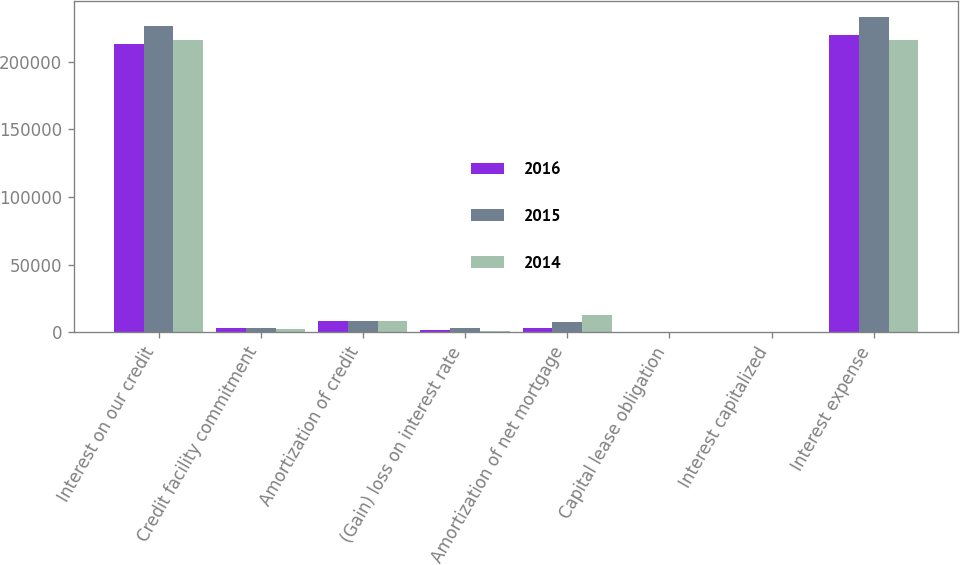Convert chart to OTSL. <chart><loc_0><loc_0><loc_500><loc_500><stacked_bar_chart><ecel><fcel>Interest on our credit<fcel>Credit facility commitment<fcel>Amortization of credit<fcel>(Gain) loss on interest rate<fcel>Amortization of net mortgage<fcel>Capital lease obligation<fcel>Interest capitalized<fcel>Interest expense<nl><fcel>2016<fcel>213540<fcel>3050<fcel>8596<fcel>1639<fcel>3414<fcel>310<fcel>469<fcel>219974<nl><fcel>2015<fcel>226207<fcel>2854<fcel>8741<fcel>3043<fcel>7482<fcel>310<fcel>594<fcel>233079<nl><fcel>2014<fcel>215830<fcel>2661<fcel>8219<fcel>1349<fcel>12891<fcel>116<fcel>444<fcel>216366<nl></chart> 